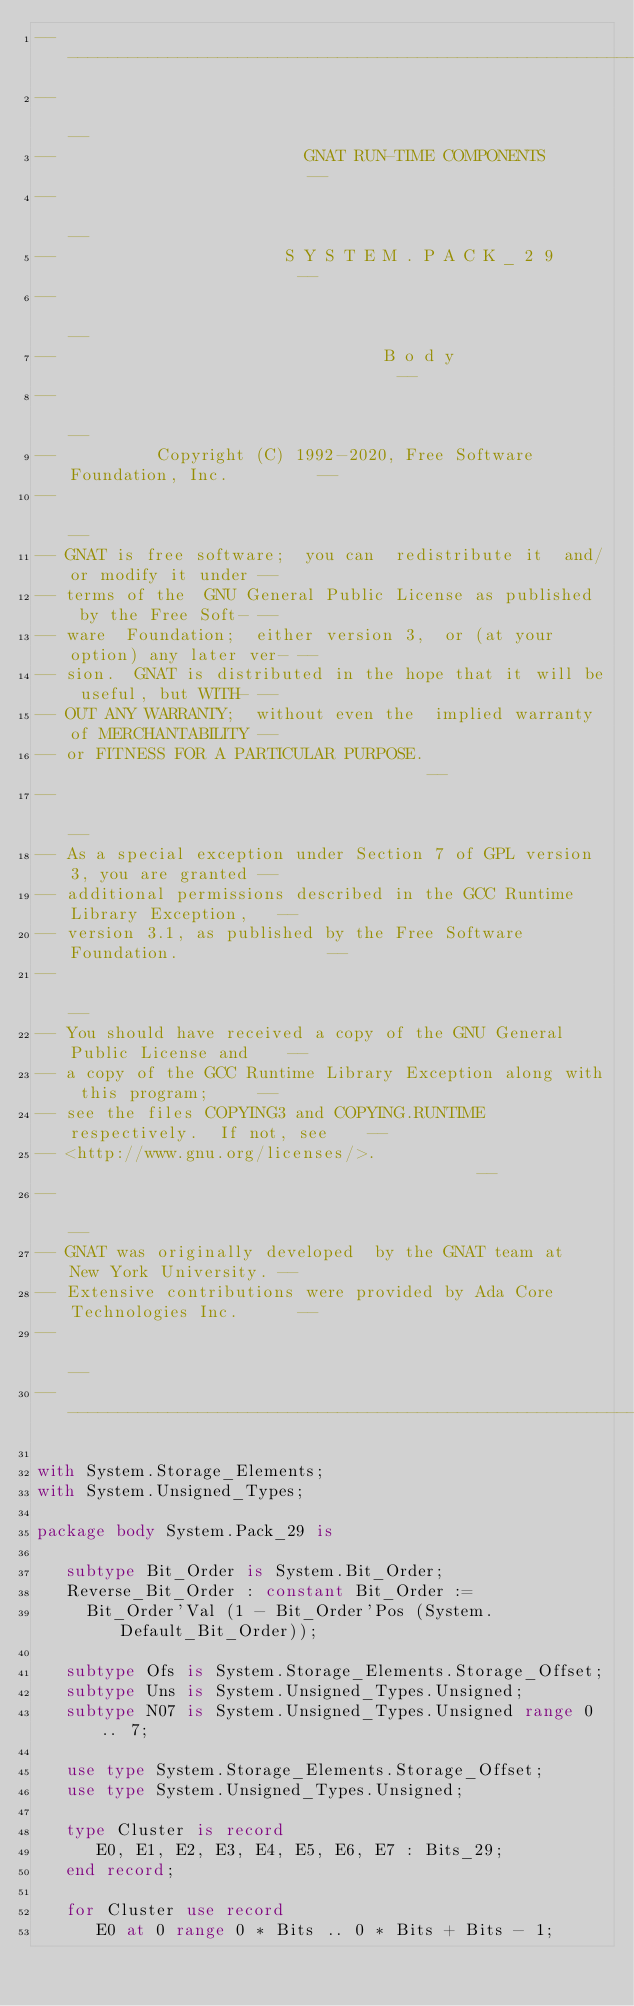Convert code to text. <code><loc_0><loc_0><loc_500><loc_500><_Ada_>------------------------------------------------------------------------------
--                                                                          --
--                         GNAT RUN-TIME COMPONENTS                         --
--                                                                          --
--                       S Y S T E M . P A C K _ 2 9                        --
--                                                                          --
--                                 B o d y                                  --
--                                                                          --
--          Copyright (C) 1992-2020, Free Software Foundation, Inc.         --
--                                                                          --
-- GNAT is free software;  you can  redistribute it  and/or modify it under --
-- terms of the  GNU General Public License as published  by the Free Soft- --
-- ware  Foundation;  either version 3,  or (at your option) any later ver- --
-- sion.  GNAT is distributed in the hope that it will be useful, but WITH- --
-- OUT ANY WARRANTY;  without even the  implied warranty of MERCHANTABILITY --
-- or FITNESS FOR A PARTICULAR PURPOSE.                                     --
--                                                                          --
-- As a special exception under Section 7 of GPL version 3, you are granted --
-- additional permissions described in the GCC Runtime Library Exception,   --
-- version 3.1, as published by the Free Software Foundation.               --
--                                                                          --
-- You should have received a copy of the GNU General Public License and    --
-- a copy of the GCC Runtime Library Exception along with this program;     --
-- see the files COPYING3 and COPYING.RUNTIME respectively.  If not, see    --
-- <http://www.gnu.org/licenses/>.                                          --
--                                                                          --
-- GNAT was originally developed  by the GNAT team at  New York University. --
-- Extensive contributions were provided by Ada Core Technologies Inc.      --
--                                                                          --
------------------------------------------------------------------------------

with System.Storage_Elements;
with System.Unsigned_Types;

package body System.Pack_29 is

   subtype Bit_Order is System.Bit_Order;
   Reverse_Bit_Order : constant Bit_Order :=
     Bit_Order'Val (1 - Bit_Order'Pos (System.Default_Bit_Order));

   subtype Ofs is System.Storage_Elements.Storage_Offset;
   subtype Uns is System.Unsigned_Types.Unsigned;
   subtype N07 is System.Unsigned_Types.Unsigned range 0 .. 7;

   use type System.Storage_Elements.Storage_Offset;
   use type System.Unsigned_Types.Unsigned;

   type Cluster is record
      E0, E1, E2, E3, E4, E5, E6, E7 : Bits_29;
   end record;

   for Cluster use record
      E0 at 0 range 0 * Bits .. 0 * Bits + Bits - 1;</code> 